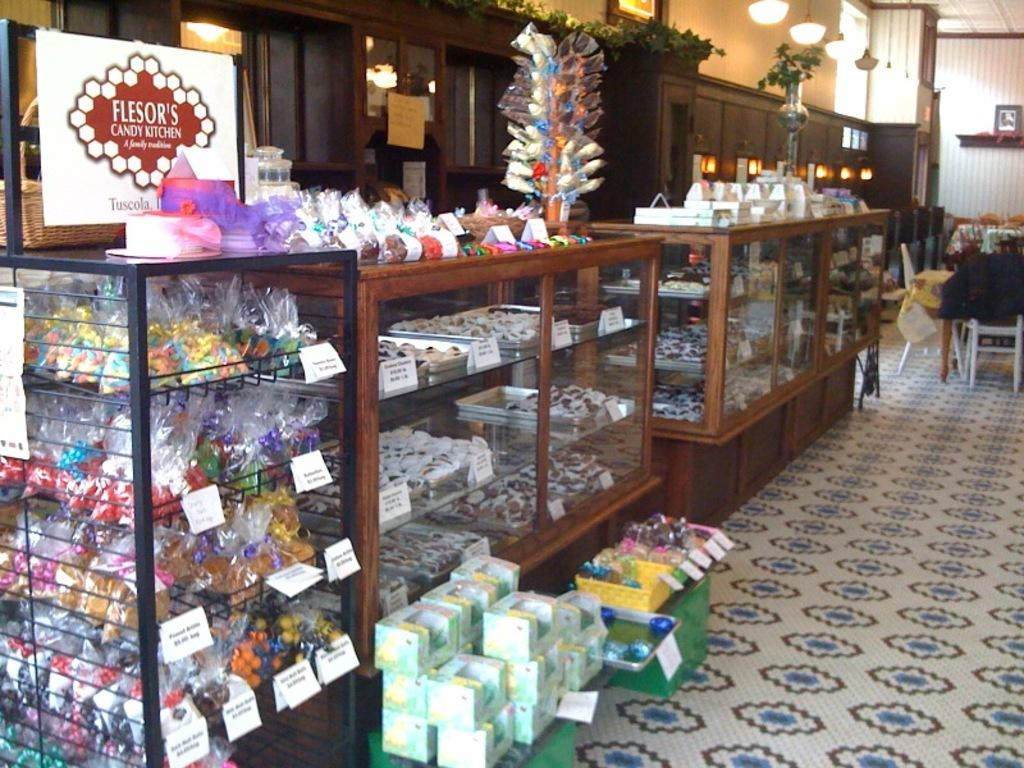<image>
Write a terse but informative summary of the picture. A store selling candy known as "Flesor's candy kitchen". 